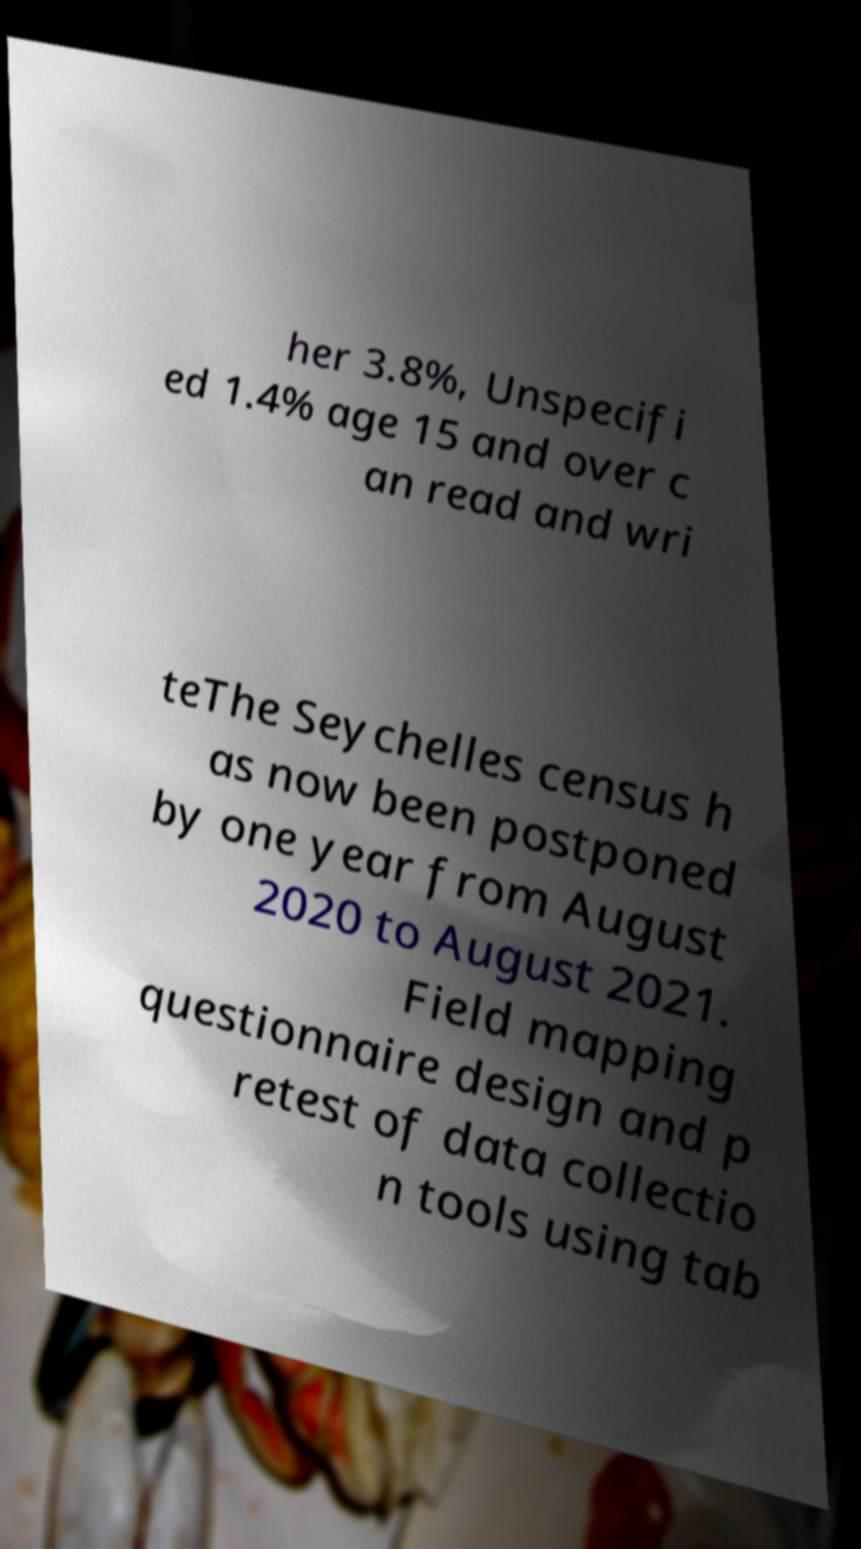Please read and relay the text visible in this image. What does it say? her 3.8%, Unspecifi ed 1.4% age 15 and over c an read and wri teThe Seychelles census h as now been postponed by one year from August 2020 to August 2021. Field mapping questionnaire design and p retest of data collectio n tools using tab 